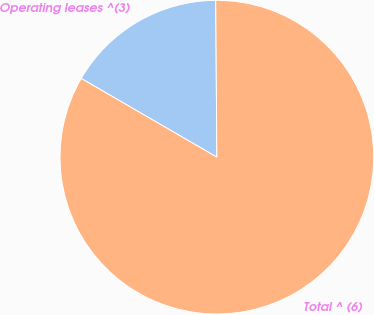<chart> <loc_0><loc_0><loc_500><loc_500><pie_chart><fcel>Operating leases ^(3)<fcel>Total ^ (6)<nl><fcel>16.52%<fcel>83.48%<nl></chart> 